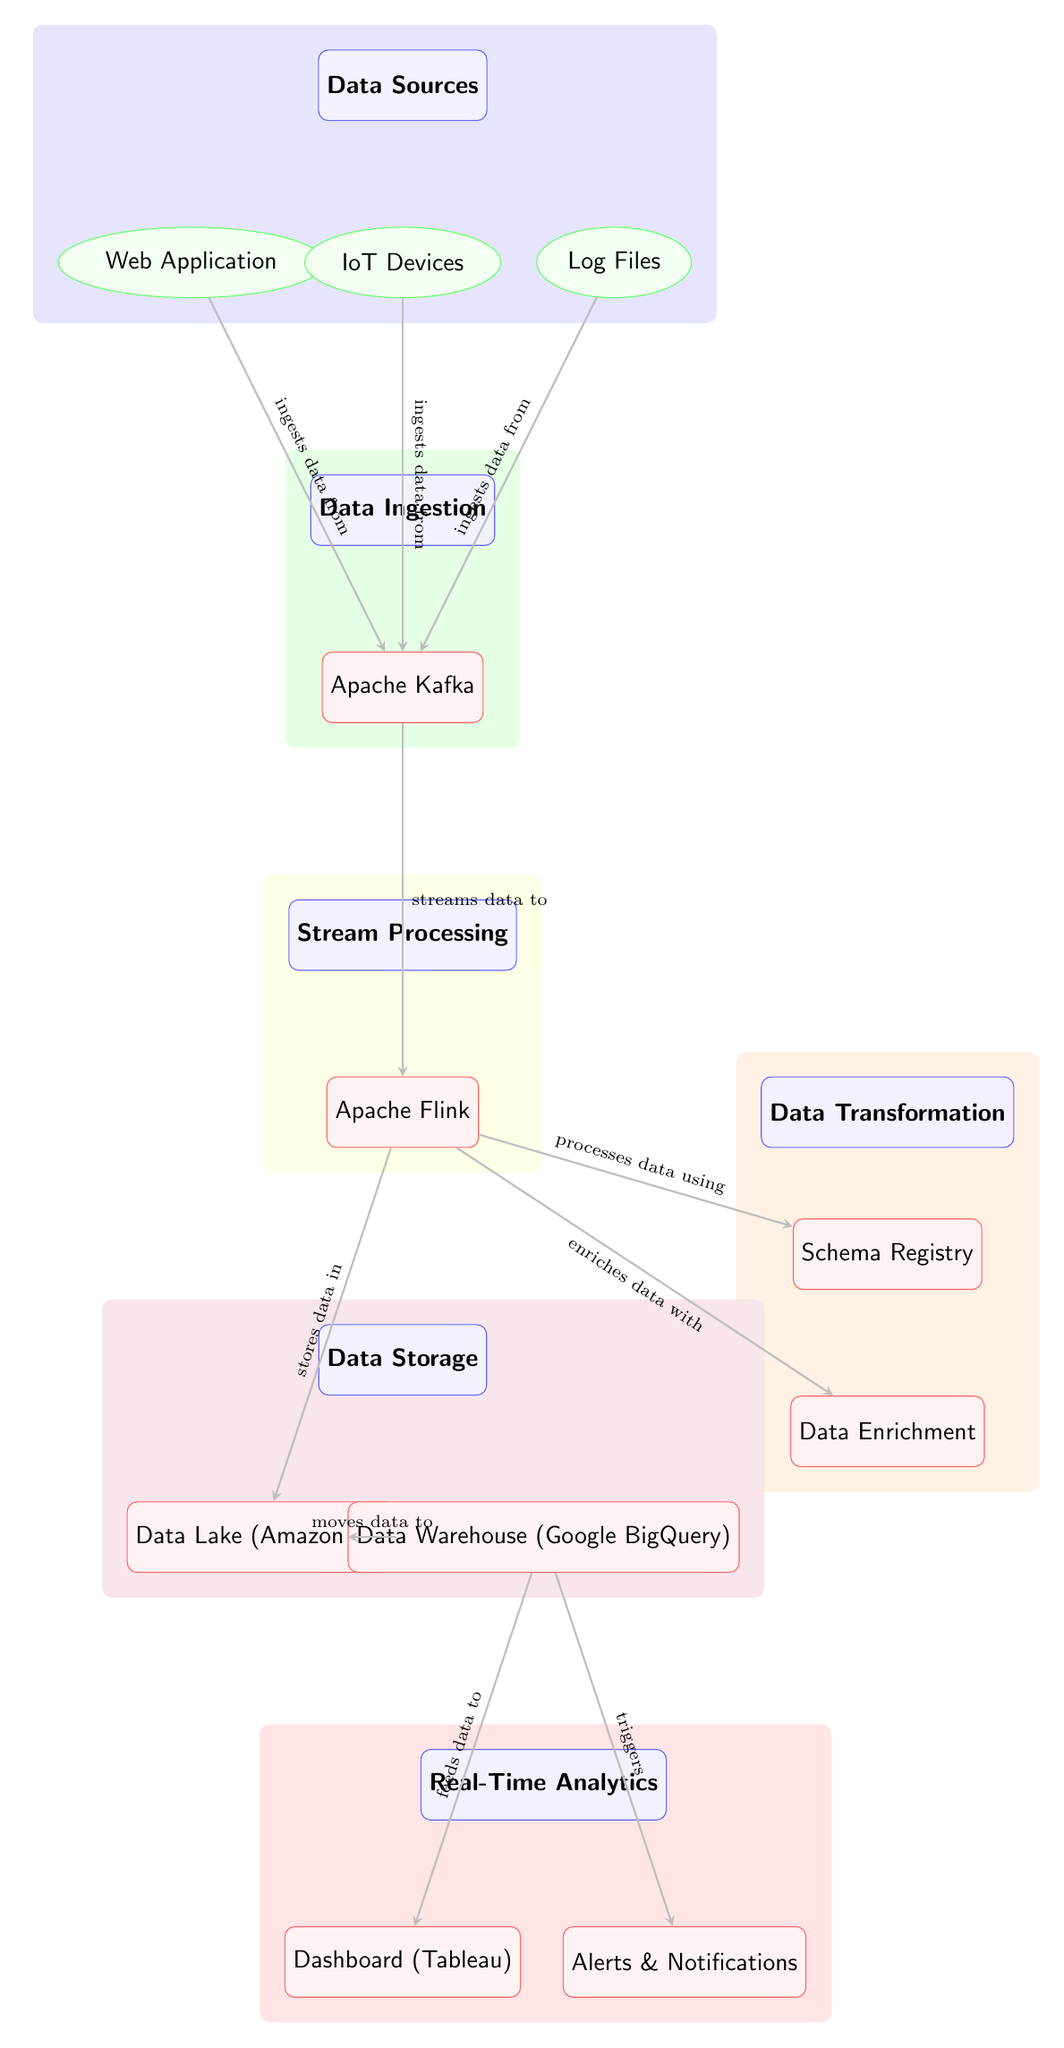What's the first category in the diagram? The first category node in the diagram is "Data Sources", which is positioned at the top of the flow.
Answer: Data Sources How many data source nodes are included in the diagram? There are three data source nodes: Web Application, IoT Devices, and Log Files, each located below the "Data Sources" category.
Answer: Three What data ingestion tool is shown in the diagram? The processing stage under the "Data Ingestion" category is labeled "Apache Kafka", indicating the tool used for data ingestion.
Answer: Apache Kafka What type of processing stage is associated with the "Stream Processing" category? The processing stage under "Stream Processing" is "Apache Flink", which is responsible for processing streaming data in the pipeline.
Answer: Apache Flink Which two storage options are presented under the "Data Storage" category? The diagram indicates two storage options: "Data Lake (Amazon S3)" and "Data Warehouse (Google BigQuery)", both are processing stages under the "Data Storage" category.
Answer: Data Lake (Amazon S3) and Data Warehouse (Google BigQuery) What triggers the alerts and notifications in the data pipeline? The arrows leading from the "Data Warehouse (Google BigQuery)" indicate that it feeds data to the "Alerts & Notifications" stage, showing that data from this node triggers them.
Answer: Data Warehouse (Google BigQuery) How many arrows point from the "Data Ingestion" stage to the "Stream Processing" stage? There is a single arrow, indicating that the data ingestion stage streams data to the stream processing stage directly.
Answer: One Which component is responsible for data enrichment in this pipeline? The diagram shows that the "Data Enrichment" processing stage is specifically designated for enriching the incoming data post-stream processing.
Answer: Data Enrichment What is the final outcome of the data flow depicted in the diagram? The final outcome of the data flow is achieved through "Real-Time Analytics", which includes the stages "Dashboard (Tableau)" and "Alerts & Notifications".
Answer: Real-Time Analytics 